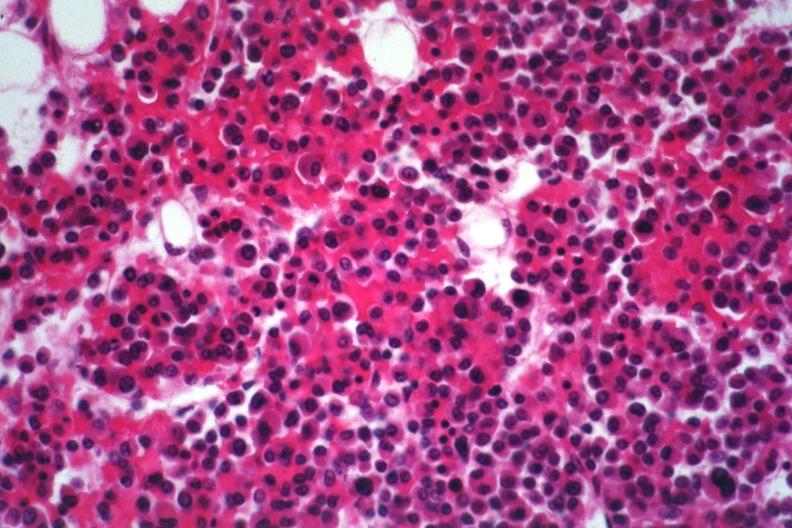what is present?
Answer the question using a single word or phrase. Multiple myeloma 